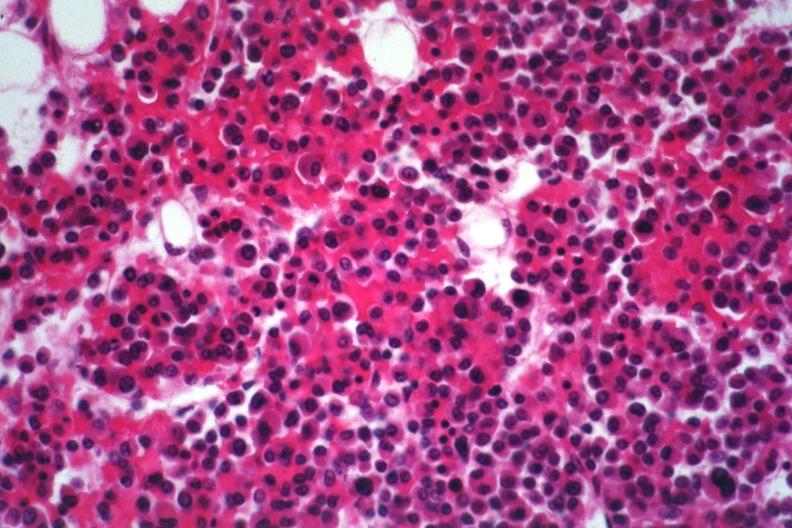what is present?
Answer the question using a single word or phrase. Multiple myeloma 